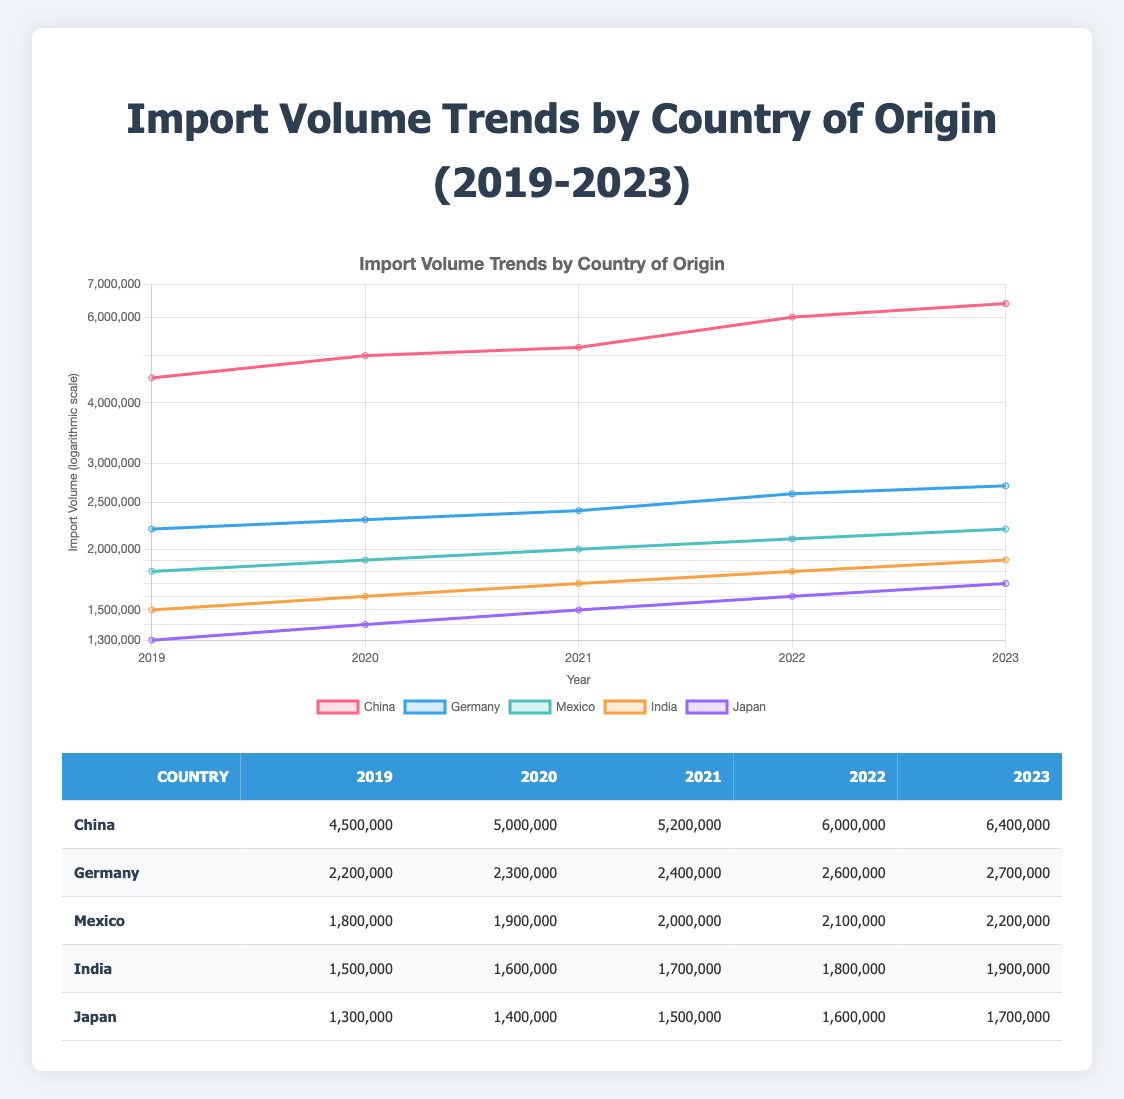What was the import volume from China in 2021? Referring to the table, under the column for China in the year 2021, the volume is listed as 5,200,000.
Answer: 5,200,000 Which country had the highest import volume in 2023? By comparing the import volumes for each country listed in 2023, China has the highest volume at 6,400,000.
Answer: China What is the average import volume from Germany over the five years? To find the average, first, sum the volumes: (2,200,000 + 2,300,000 + 2,400,000 + 2,600,000 + 2,700,000) = 12,200,000. Then divide by 5: 12,200,000 / 5 = 2,440,000.
Answer: 2,440,000 Did Japan's import volume increase every year from 2019 to 2023? Reviewing the volumes for Japan from 2019 to 2023, they are: 1,300,000, 1,400,000, 1,500,000, 1,600,000, and 1,700,000. Since these values consistently increase, the answer is yes.
Answer: Yes What was the total import volume from Mexico from 2019 to 2022? To calculate the total, sum the volumes: (1,800,000 + 1,900,000 + 2,000,000 + 2,100,000) = 7,800,000.
Answer: 7,800,000 Which country showed the smallest increase in import volume from 2022 to 2023? To determine this, calculate the differences for each country: China (400,000), Germany (100,000), Mexico (100,000), India (100,000), Japan (100,000). The smallest increase is for Germany, Mexico, India, and Japan, each at 100,000.
Answer: Germany, Mexico, India, Japan What was the import volume from India in 2022? From the table, India's volume for the year 2022 is clearly stated as 1,800,000.
Answer: 1,800,000 What is the percentage increase in import volume from China between 2019 and 2023? First, find the difference in volume: 6,400,000 - 4,500,000 = 1,900,000. Then calculate the percentage increase: (1,900,000 / 4,500,000) * 100 = approximately 42.22%.
Answer: 42.22% 